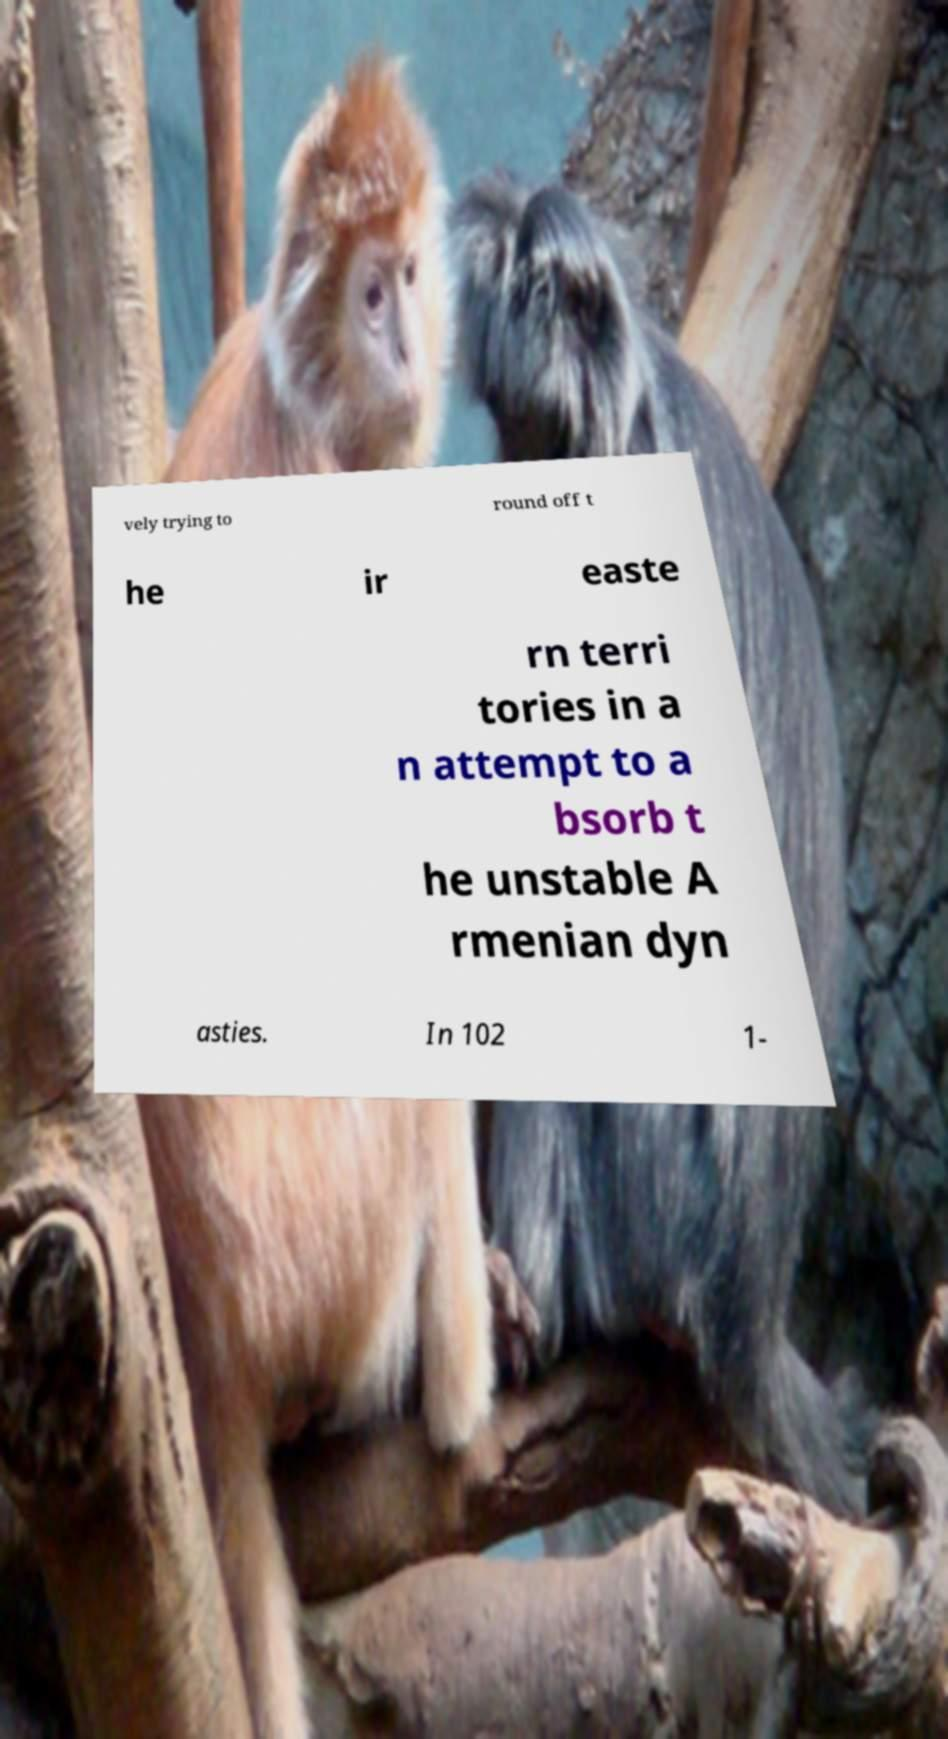Can you read and provide the text displayed in the image?This photo seems to have some interesting text. Can you extract and type it out for me? vely trying to round off t he ir easte rn terri tories in a n attempt to a bsorb t he unstable A rmenian dyn asties. In 102 1- 